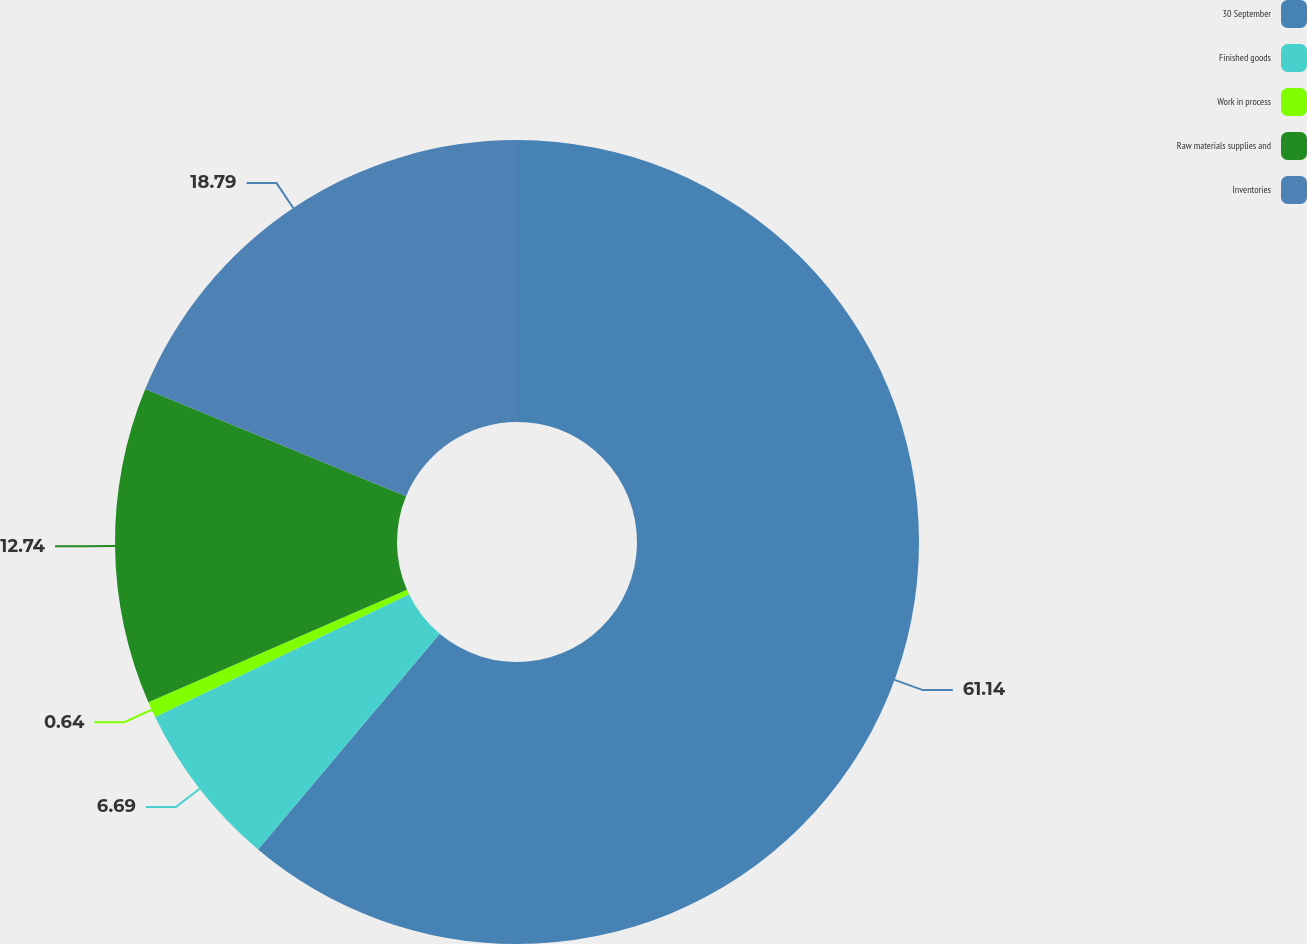Convert chart to OTSL. <chart><loc_0><loc_0><loc_500><loc_500><pie_chart><fcel>30 September<fcel>Finished goods<fcel>Work in process<fcel>Raw materials supplies and<fcel>Inventories<nl><fcel>61.14%<fcel>6.69%<fcel>0.64%<fcel>12.74%<fcel>18.79%<nl></chart> 